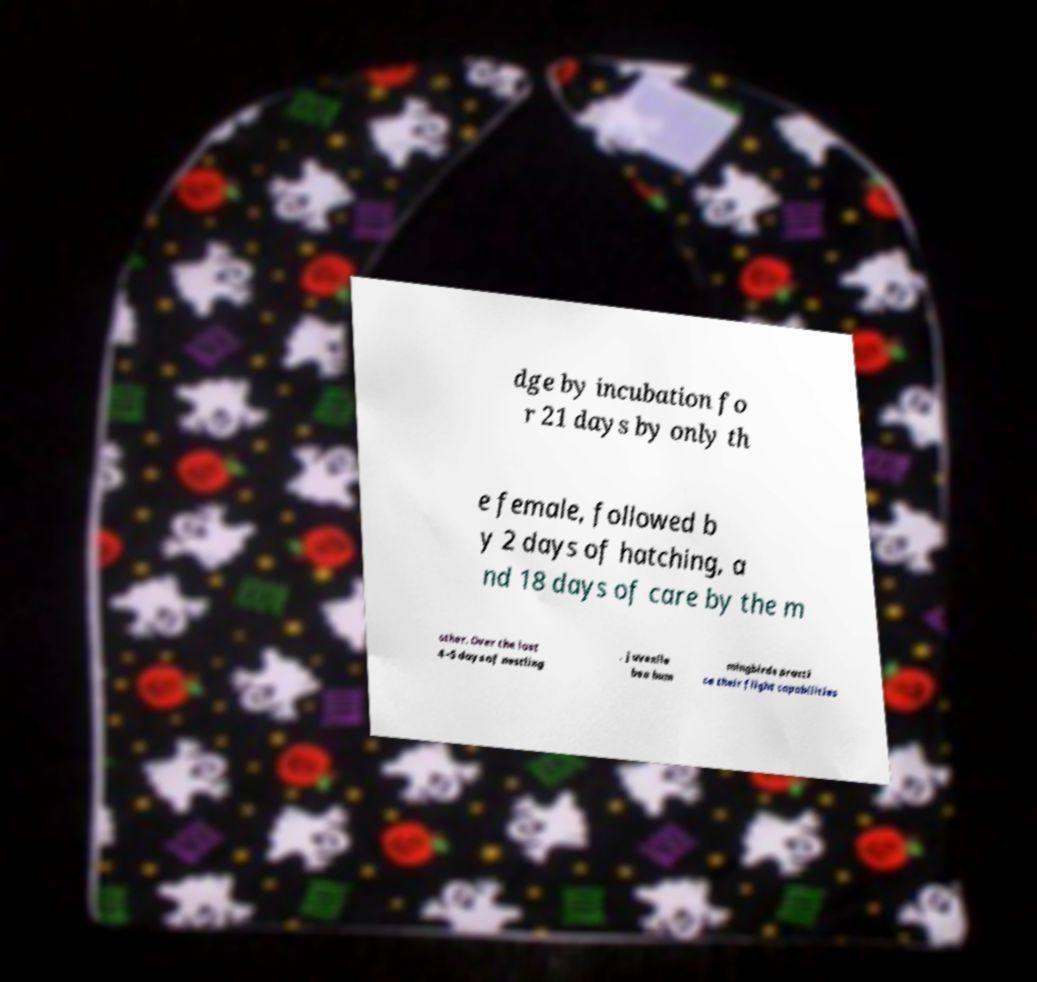There's text embedded in this image that I need extracted. Can you transcribe it verbatim? dge by incubation fo r 21 days by only th e female, followed b y 2 days of hatching, a nd 18 days of care by the m other. Over the last 4–5 days of nestling , juvenile bee hum mingbirds practi ce their flight capabilities 